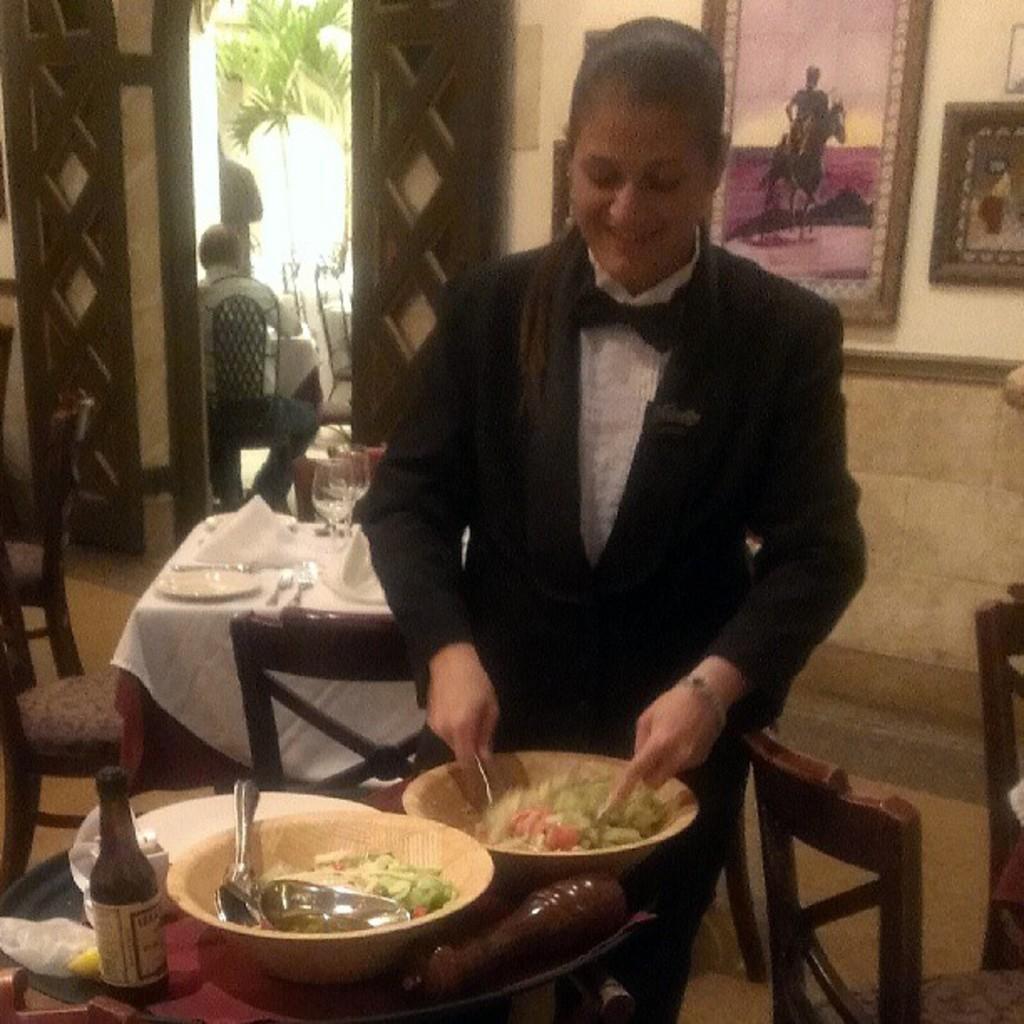Describe this image in one or two sentences. This woman in black suit is standing. In-front of this woman there is a table, on a table there is a plate, bowls, spoon and bottle. A pictures on a wall. This are chairs. Outside of this door there are plants. Persons are sitting on a chair. 